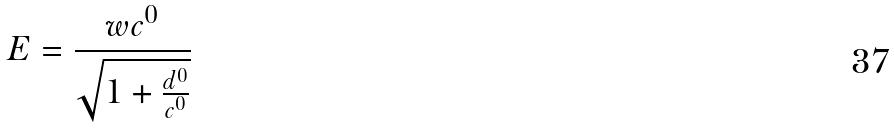<formula> <loc_0><loc_0><loc_500><loc_500>E = \frac { w c ^ { 0 } } { \sqrt { 1 + \frac { d ^ { 0 } } { c ^ { 0 } } } }</formula> 